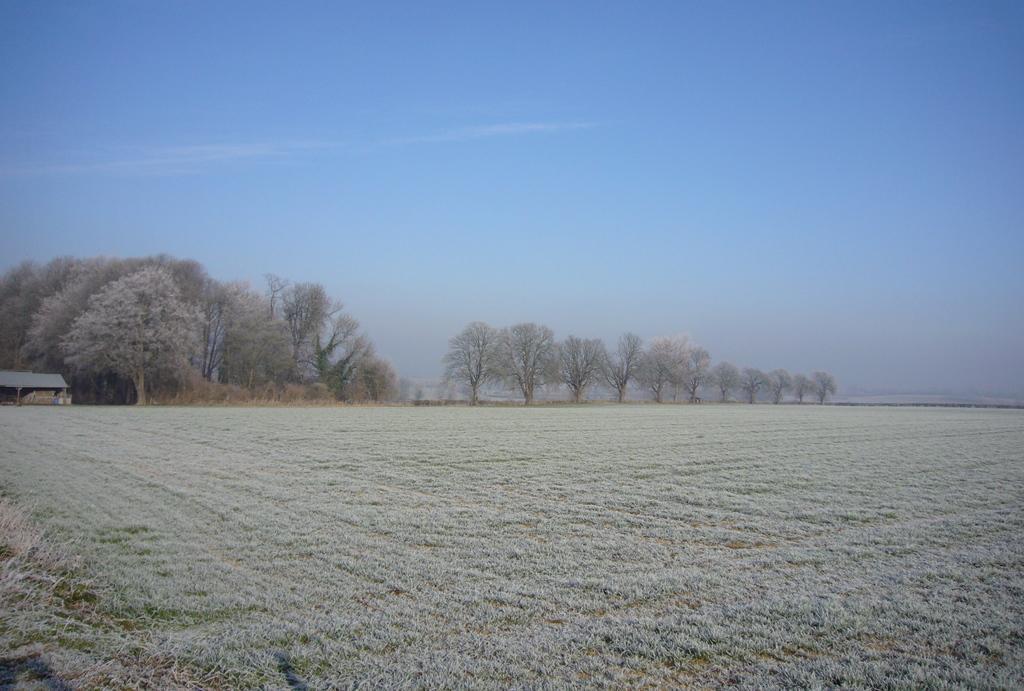How would you summarize this image in a sentence or two? These are the trees in the middle of an image, at the top it is the blue color sky. 